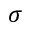Convert formula to latex. <formula><loc_0><loc_0><loc_500><loc_500>\sigma</formula> 